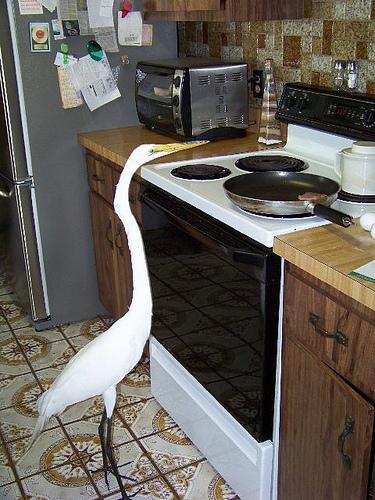What is the animal standing on?
Keep it brief. Floor. What kind of oven is in this picture?
Concise answer only. Electric. What is odd about this picture?
Concise answer only. Bird in kitchen. Where are the salt and pepper shakers in this kitchen?
Give a very brief answer. Stove. Is there a frying pan in the photo?
Keep it brief. Yes. 